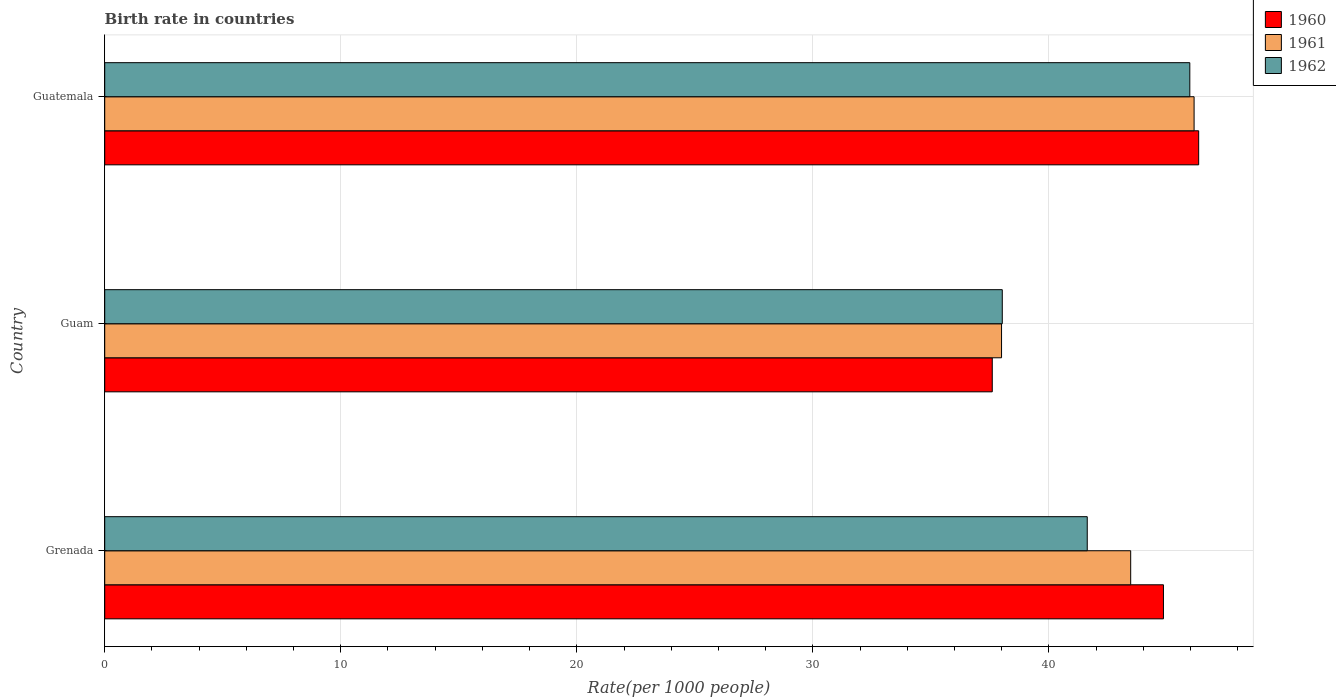How many different coloured bars are there?
Give a very brief answer. 3. Are the number of bars per tick equal to the number of legend labels?
Give a very brief answer. Yes. What is the label of the 2nd group of bars from the top?
Your answer should be compact. Guam. What is the birth rate in 1961 in Guatemala?
Give a very brief answer. 46.15. Across all countries, what is the maximum birth rate in 1962?
Your response must be concise. 45.97. Across all countries, what is the minimum birth rate in 1961?
Your answer should be compact. 37.99. In which country was the birth rate in 1962 maximum?
Your response must be concise. Guatemala. In which country was the birth rate in 1961 minimum?
Offer a terse response. Guam. What is the total birth rate in 1961 in the graph?
Your answer should be very brief. 127.61. What is the difference between the birth rate in 1962 in Guam and that in Guatemala?
Give a very brief answer. -7.95. What is the difference between the birth rate in 1962 in Guatemala and the birth rate in 1961 in Guam?
Offer a terse response. 7.98. What is the average birth rate in 1962 per country?
Keep it short and to the point. 41.87. What is the difference between the birth rate in 1960 and birth rate in 1962 in Guatemala?
Keep it short and to the point. 0.38. In how many countries, is the birth rate in 1962 greater than 6 ?
Your answer should be very brief. 3. What is the ratio of the birth rate in 1962 in Grenada to that in Guam?
Your answer should be very brief. 1.09. What is the difference between the highest and the second highest birth rate in 1960?
Provide a succinct answer. 1.49. What is the difference between the highest and the lowest birth rate in 1962?
Ensure brevity in your answer.  7.95. What does the 1st bar from the top in Guam represents?
Provide a short and direct response. 1962. What does the 2nd bar from the bottom in Guam represents?
Give a very brief answer. 1961. Is it the case that in every country, the sum of the birth rate in 1960 and birth rate in 1962 is greater than the birth rate in 1961?
Offer a terse response. Yes. Are all the bars in the graph horizontal?
Offer a terse response. Yes. Are the values on the major ticks of X-axis written in scientific E-notation?
Offer a very short reply. No. How many legend labels are there?
Your answer should be compact. 3. What is the title of the graph?
Ensure brevity in your answer.  Birth rate in countries. Does "1996" appear as one of the legend labels in the graph?
Provide a short and direct response. No. What is the label or title of the X-axis?
Ensure brevity in your answer.  Rate(per 1000 people). What is the label or title of the Y-axis?
Keep it short and to the point. Country. What is the Rate(per 1000 people) in 1960 in Grenada?
Ensure brevity in your answer.  44.85. What is the Rate(per 1000 people) of 1961 in Grenada?
Offer a terse response. 43.47. What is the Rate(per 1000 people) of 1962 in Grenada?
Keep it short and to the point. 41.62. What is the Rate(per 1000 people) in 1960 in Guam?
Keep it short and to the point. 37.6. What is the Rate(per 1000 people) of 1961 in Guam?
Provide a short and direct response. 37.99. What is the Rate(per 1000 people) in 1962 in Guam?
Your answer should be compact. 38.02. What is the Rate(per 1000 people) of 1960 in Guatemala?
Give a very brief answer. 46.34. What is the Rate(per 1000 people) in 1961 in Guatemala?
Give a very brief answer. 46.15. What is the Rate(per 1000 people) in 1962 in Guatemala?
Make the answer very short. 45.97. Across all countries, what is the maximum Rate(per 1000 people) of 1960?
Provide a short and direct response. 46.34. Across all countries, what is the maximum Rate(per 1000 people) in 1961?
Give a very brief answer. 46.15. Across all countries, what is the maximum Rate(per 1000 people) of 1962?
Provide a short and direct response. 45.97. Across all countries, what is the minimum Rate(per 1000 people) of 1960?
Keep it short and to the point. 37.6. Across all countries, what is the minimum Rate(per 1000 people) in 1961?
Make the answer very short. 37.99. Across all countries, what is the minimum Rate(per 1000 people) in 1962?
Make the answer very short. 38.02. What is the total Rate(per 1000 people) in 1960 in the graph?
Offer a terse response. 128.8. What is the total Rate(per 1000 people) in 1961 in the graph?
Make the answer very short. 127.61. What is the total Rate(per 1000 people) in 1962 in the graph?
Your answer should be very brief. 125.62. What is the difference between the Rate(per 1000 people) in 1960 in Grenada and that in Guam?
Your answer should be compact. 7.25. What is the difference between the Rate(per 1000 people) of 1961 in Grenada and that in Guam?
Offer a terse response. 5.47. What is the difference between the Rate(per 1000 people) in 1962 in Grenada and that in Guam?
Ensure brevity in your answer.  3.6. What is the difference between the Rate(per 1000 people) in 1960 in Grenada and that in Guatemala?
Provide a succinct answer. -1.49. What is the difference between the Rate(per 1000 people) of 1961 in Grenada and that in Guatemala?
Make the answer very short. -2.69. What is the difference between the Rate(per 1000 people) in 1962 in Grenada and that in Guatemala?
Provide a short and direct response. -4.34. What is the difference between the Rate(per 1000 people) in 1960 in Guam and that in Guatemala?
Make the answer very short. -8.74. What is the difference between the Rate(per 1000 people) in 1961 in Guam and that in Guatemala?
Make the answer very short. -8.16. What is the difference between the Rate(per 1000 people) in 1962 in Guam and that in Guatemala?
Provide a short and direct response. -7.95. What is the difference between the Rate(per 1000 people) in 1960 in Grenada and the Rate(per 1000 people) in 1961 in Guam?
Your response must be concise. 6.86. What is the difference between the Rate(per 1000 people) in 1960 in Grenada and the Rate(per 1000 people) in 1962 in Guam?
Give a very brief answer. 6.83. What is the difference between the Rate(per 1000 people) of 1961 in Grenada and the Rate(per 1000 people) of 1962 in Guam?
Offer a very short reply. 5.44. What is the difference between the Rate(per 1000 people) of 1960 in Grenada and the Rate(per 1000 people) of 1961 in Guatemala?
Provide a succinct answer. -1.3. What is the difference between the Rate(per 1000 people) of 1960 in Grenada and the Rate(per 1000 people) of 1962 in Guatemala?
Offer a terse response. -1.12. What is the difference between the Rate(per 1000 people) of 1961 in Grenada and the Rate(per 1000 people) of 1962 in Guatemala?
Your answer should be very brief. -2.5. What is the difference between the Rate(per 1000 people) of 1960 in Guam and the Rate(per 1000 people) of 1961 in Guatemala?
Make the answer very short. -8.55. What is the difference between the Rate(per 1000 people) in 1960 in Guam and the Rate(per 1000 people) in 1962 in Guatemala?
Your response must be concise. -8.37. What is the difference between the Rate(per 1000 people) of 1961 in Guam and the Rate(per 1000 people) of 1962 in Guatemala?
Offer a very short reply. -7.98. What is the average Rate(per 1000 people) of 1960 per country?
Provide a succinct answer. 42.93. What is the average Rate(per 1000 people) of 1961 per country?
Offer a terse response. 42.54. What is the average Rate(per 1000 people) in 1962 per country?
Keep it short and to the point. 41.87. What is the difference between the Rate(per 1000 people) in 1960 and Rate(per 1000 people) in 1961 in Grenada?
Offer a very short reply. 1.39. What is the difference between the Rate(per 1000 people) of 1960 and Rate(per 1000 people) of 1962 in Grenada?
Provide a short and direct response. 3.23. What is the difference between the Rate(per 1000 people) in 1961 and Rate(per 1000 people) in 1962 in Grenada?
Make the answer very short. 1.84. What is the difference between the Rate(per 1000 people) of 1960 and Rate(per 1000 people) of 1961 in Guam?
Offer a terse response. -0.39. What is the difference between the Rate(per 1000 people) of 1960 and Rate(per 1000 people) of 1962 in Guam?
Provide a short and direct response. -0.42. What is the difference between the Rate(per 1000 people) in 1961 and Rate(per 1000 people) in 1962 in Guam?
Your response must be concise. -0.03. What is the difference between the Rate(per 1000 people) in 1960 and Rate(per 1000 people) in 1961 in Guatemala?
Offer a terse response. 0.19. What is the difference between the Rate(per 1000 people) in 1960 and Rate(per 1000 people) in 1962 in Guatemala?
Ensure brevity in your answer.  0.38. What is the difference between the Rate(per 1000 people) of 1961 and Rate(per 1000 people) of 1962 in Guatemala?
Your answer should be compact. 0.18. What is the ratio of the Rate(per 1000 people) of 1960 in Grenada to that in Guam?
Your answer should be compact. 1.19. What is the ratio of the Rate(per 1000 people) in 1961 in Grenada to that in Guam?
Your answer should be very brief. 1.14. What is the ratio of the Rate(per 1000 people) of 1962 in Grenada to that in Guam?
Make the answer very short. 1.09. What is the ratio of the Rate(per 1000 people) of 1960 in Grenada to that in Guatemala?
Keep it short and to the point. 0.97. What is the ratio of the Rate(per 1000 people) in 1961 in Grenada to that in Guatemala?
Provide a succinct answer. 0.94. What is the ratio of the Rate(per 1000 people) of 1962 in Grenada to that in Guatemala?
Provide a succinct answer. 0.91. What is the ratio of the Rate(per 1000 people) of 1960 in Guam to that in Guatemala?
Ensure brevity in your answer.  0.81. What is the ratio of the Rate(per 1000 people) in 1961 in Guam to that in Guatemala?
Give a very brief answer. 0.82. What is the ratio of the Rate(per 1000 people) of 1962 in Guam to that in Guatemala?
Provide a short and direct response. 0.83. What is the difference between the highest and the second highest Rate(per 1000 people) in 1960?
Offer a terse response. 1.49. What is the difference between the highest and the second highest Rate(per 1000 people) in 1961?
Your response must be concise. 2.69. What is the difference between the highest and the second highest Rate(per 1000 people) of 1962?
Give a very brief answer. 4.34. What is the difference between the highest and the lowest Rate(per 1000 people) in 1960?
Your answer should be very brief. 8.74. What is the difference between the highest and the lowest Rate(per 1000 people) of 1961?
Keep it short and to the point. 8.16. What is the difference between the highest and the lowest Rate(per 1000 people) in 1962?
Give a very brief answer. 7.95. 